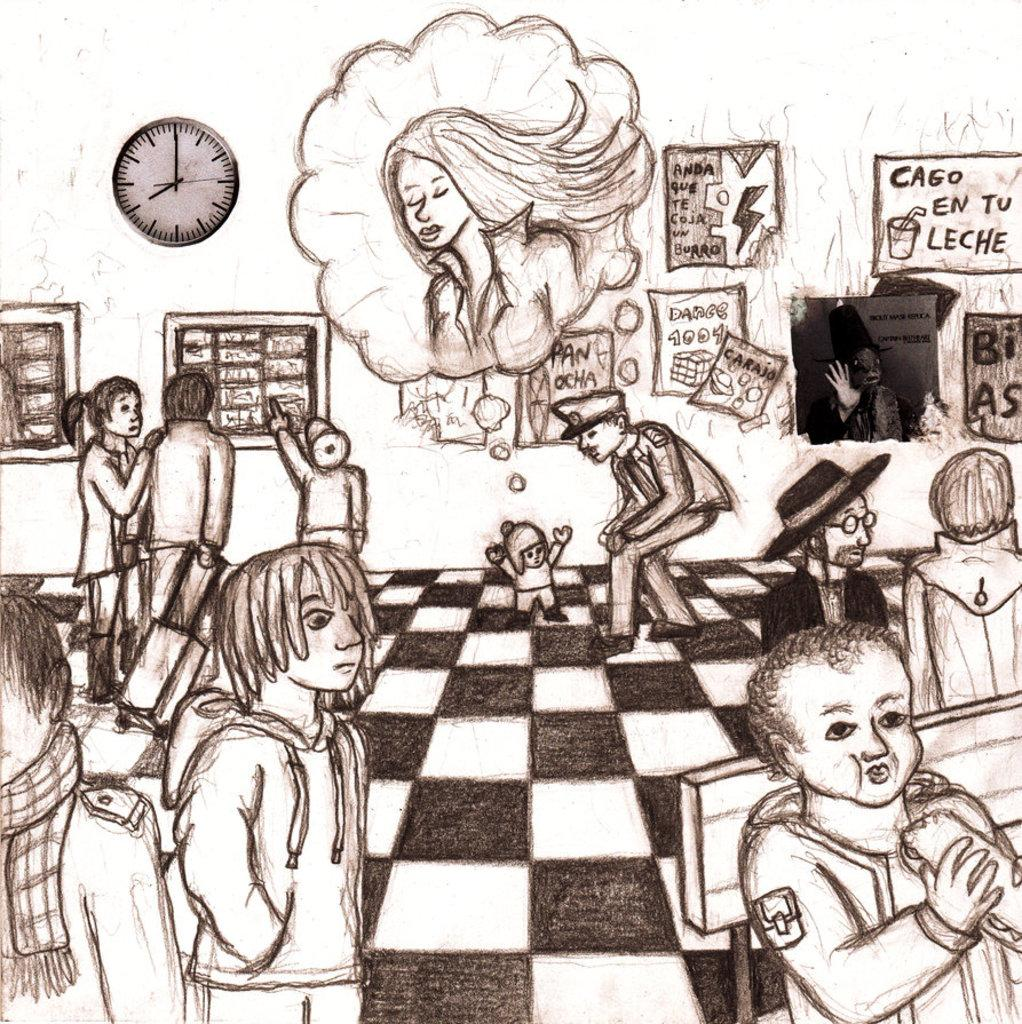<image>
Summarize the visual content of the image. A black and white sketch with a sign reading "Cago en tu leche" on the back wall. 